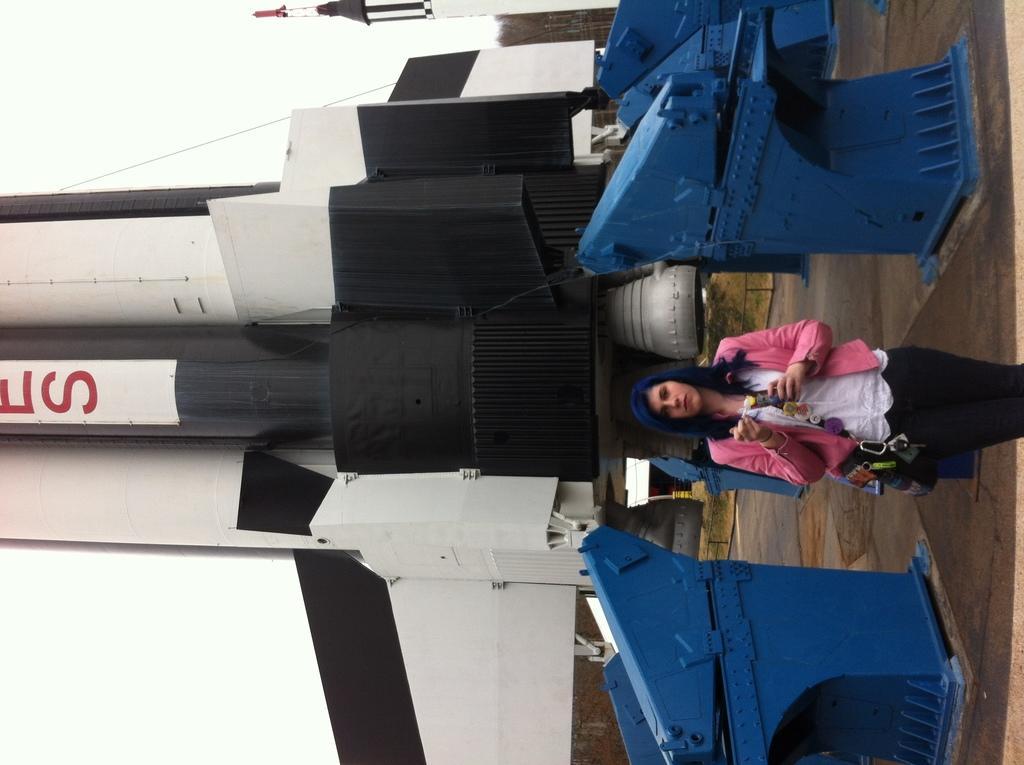Please provide a concise description of this image. On the right side of the image there is a lady standing. Behind her there is a rocket. And also there are blue color things on the ground. 